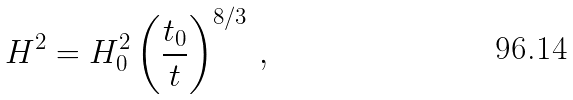<formula> <loc_0><loc_0><loc_500><loc_500>H ^ { 2 } = H _ { 0 } ^ { 2 } \left ( \frac { t _ { 0 } } { t } \right ) ^ { 8 / 3 } \, ,</formula> 